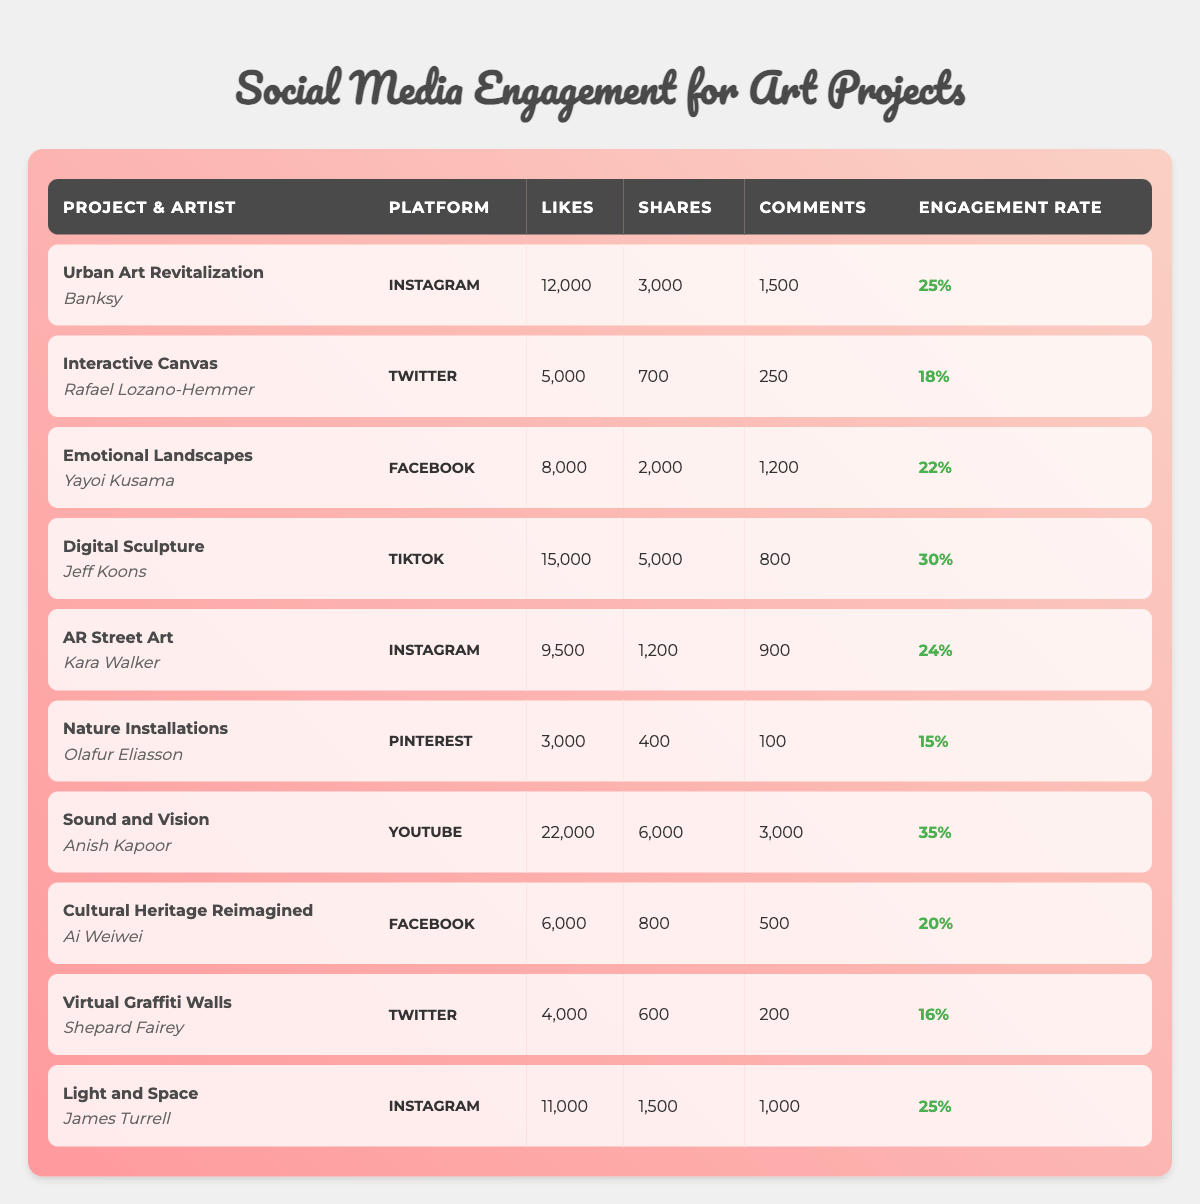What is the highest engagement rate among the art projects? The engagement rates for the projects are as follows: 25%, 18%, 22%, 30%, 24%, 15%, 35%, 20%, 16%, and 25%. The highest value is 35%, attributed to "Sound and Vision" by Anish Kapoor.
Answer: 35% Which project received the most likes? The likes for each project are: 12,000, 5,000, 8,000, 15,000, 9,500, 3,000, 22,000, 6,000, 4,000, and 11,000. The highest value is 22,000 for "Sound and Vision" by Anish Kapoor.
Answer: 22,000 What is the average number of shares across all projects? The total shares are 3,000 + 700 + 2,000 + 5,000 + 1,200 + 400 + 6,000 + 800 + 600 + 1,500 = 21,100 shares. There are 10 projects, so the average is 21,100 / 10 = 2,110 shares.
Answer: 2,110 Did "Interactive Canvas" get more comments than "Cultural Heritage Reimagined"? "Interactive Canvas" received 250 comments while "Cultural Heritage Reimagined" received 500 comments. Since 250 is less than 500, the answer is no.
Answer: No Which artist had the highest overall engagement across all platforms? First, we need to consider the engagement rates and likes which contribute to overall engagement. The highest engagement rate is 35% from "Sound and Vision" (22,000 likes) = 0.35 * 22,000 = 7,700. The second-highest is "Digital Sculpture" with 30% (15,000 likes) = 0.30 * 15,000 = 4,500. Finally, "Light and Space" has 25% (11,000 likes) = 0.25 * 11,000 = 2,750. Thus, the artist with the highest overall engagement is Anish Kapoor with 7,700.
Answer: Anish Kapoor How many projects were posted on Instagram? The projects on Instagram are "Urban Art Revitalization," "AR Street Art," and "Light and Space," totaling three.
Answer: 3 Is there a project with more shares than likes? All projects have shares that are less than likes except for "Nature Installations," which has 400 shares against 3,000 likes. Thus, there is indeed a project with more shares than likes.
Answer: Yes What is the total number of comments across all platforms? To find the total comments, we sum: 1,500 + 250 + 1,200 + 800 + 900 + 100 + 3,000 + 500 + 200 + 1,000 = 9,450.
Answer: 9,450 Which platform had the least engagement as measured by engagement rate? Looking at the engagement rates: 25%, 18%, 22%, 30%, 24%, 15%, 35%, 20%, 16%, and 25%, the least engagement rate is 15% from "Nature Installations" on Pinterest.
Answer: 15% Which project had the most shares relative to its likes? To find this, we calculate shares/likes for each project: "Urban Art Revitalization" = 3000/12000 = 0.25, "Interactive Canvas" = 700/5000 = 0.14, "Emotional Landscapes" = 2000/8000 = 0.25, "Digital Sculpture" = 5000/15000 = 0.33, "AR Street Art" = 1200/9500 = 0.13, "Nature Installations" = 400/3000 = 0.13, "Sound and Vision" = 6000/22000 = 0.27, "Cultural Heritage Reimagined" = 800/6000 = 0.13, "Virtual Graffiti Walls" = 600/4000 = 0.15, "Light and Space" = 1500/11000 = 0.14. The highest ratio is 0.33 for "Digital Sculpture."
Answer: Digital Sculpture 